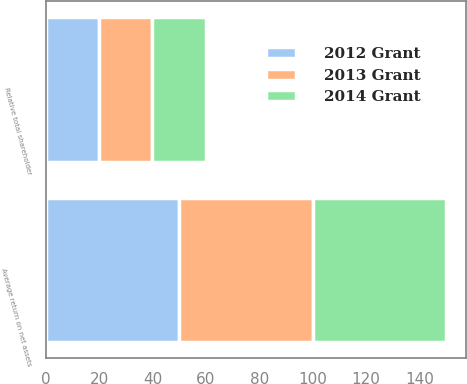Convert chart to OTSL. <chart><loc_0><loc_0><loc_500><loc_500><stacked_bar_chart><ecel><fcel>Average return on net assets<fcel>Relative total shareholder<nl><fcel>2012 Grant<fcel>50<fcel>20<nl><fcel>2013 Grant<fcel>50<fcel>20<nl><fcel>2014 Grant<fcel>50<fcel>20<nl></chart> 